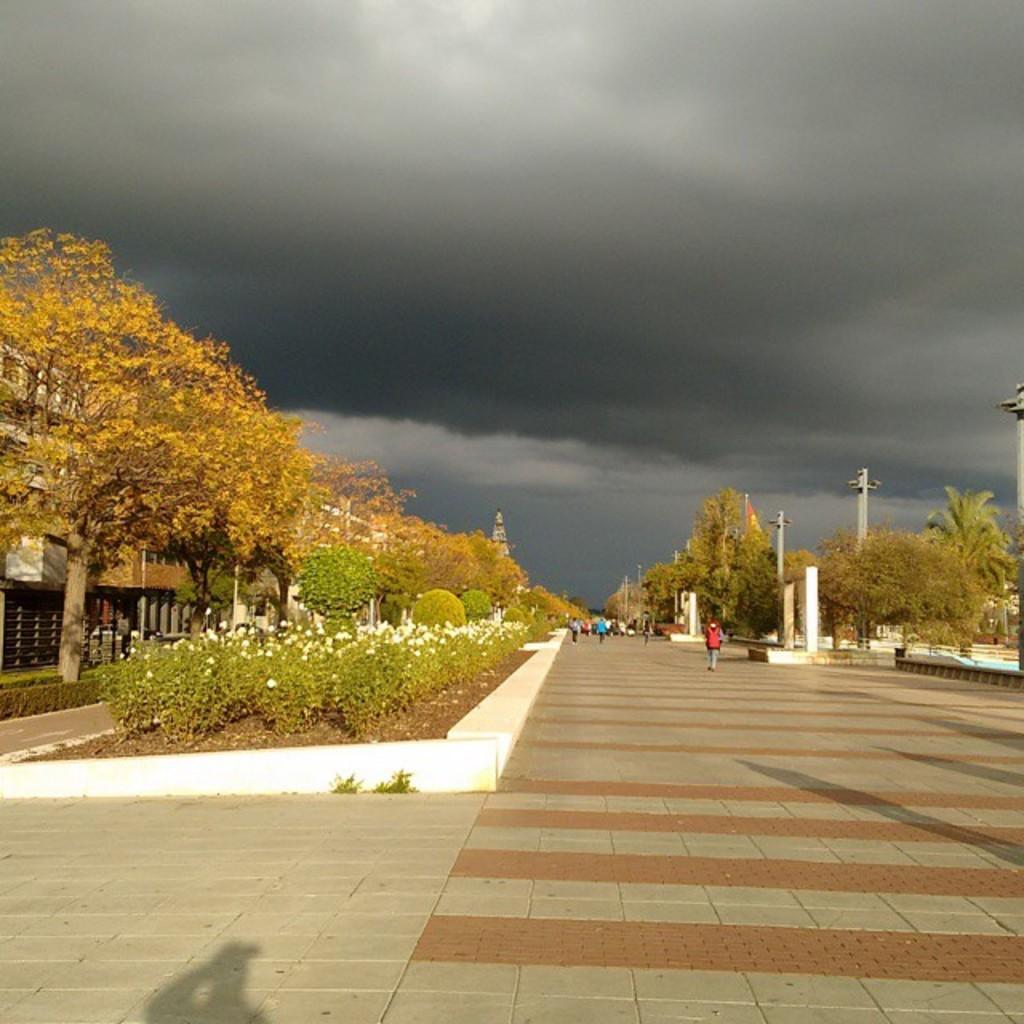Can you describe this image briefly? In this picture there are people those who are walking in the center of the image and there are trees on the right and left side of the image, there are poles on the right side of the image and there are buildings on the left side of the image. 